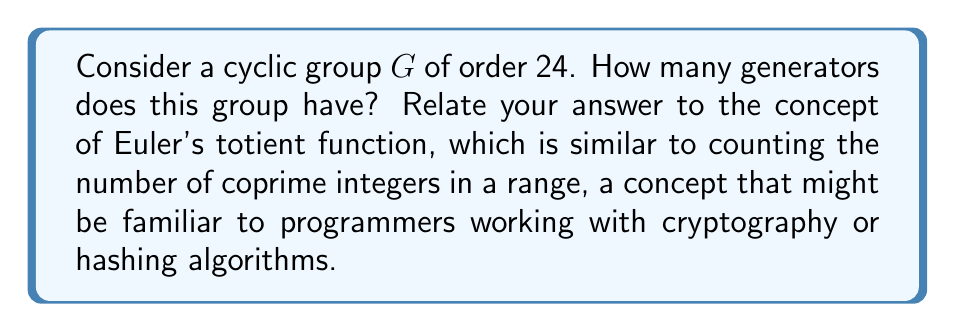Could you help me with this problem? To solve this problem, we'll follow these steps:

1) In a cyclic group of order $n$, an element $a$ is a generator if and only if $\gcd(a,n) = 1$.

2) The number of generators in a cyclic group of order $n$ is equal to the value of Euler's totient function $\phi(n)$.

3) For a cyclic group of order 24, we need to calculate $\phi(24)$.

4) To calculate $\phi(24)$:
   
   a) First, factor 24: $24 = 2^3 \times 3$
   
   b) For prime powers $p^k$, $\phi(p^k) = p^k - p^{k-1}$
   
   c) The totient function is multiplicative, so for distinct primes:
      $\phi(ab) = \phi(a) \times \phi(b)$

5) Therefore:
   
   $$\phi(24) = \phi(2^3) \times \phi(3)$$
   
   $$= (2^3 - 2^2) \times (3 - 1)$$
   
   $$= (8 - 4) \times 2$$
   
   $$= 4 \times 2 = 8$$

6) Thus, the cyclic group of order 24 has 8 generators.

This concept is analogous to finding the number of integers between 1 and 24 that are coprime to 24, which could be useful in various programming contexts, such as implementing certain cryptographic algorithms or hash functions.
Answer: The cyclic group of order 24 has 8 generators. 